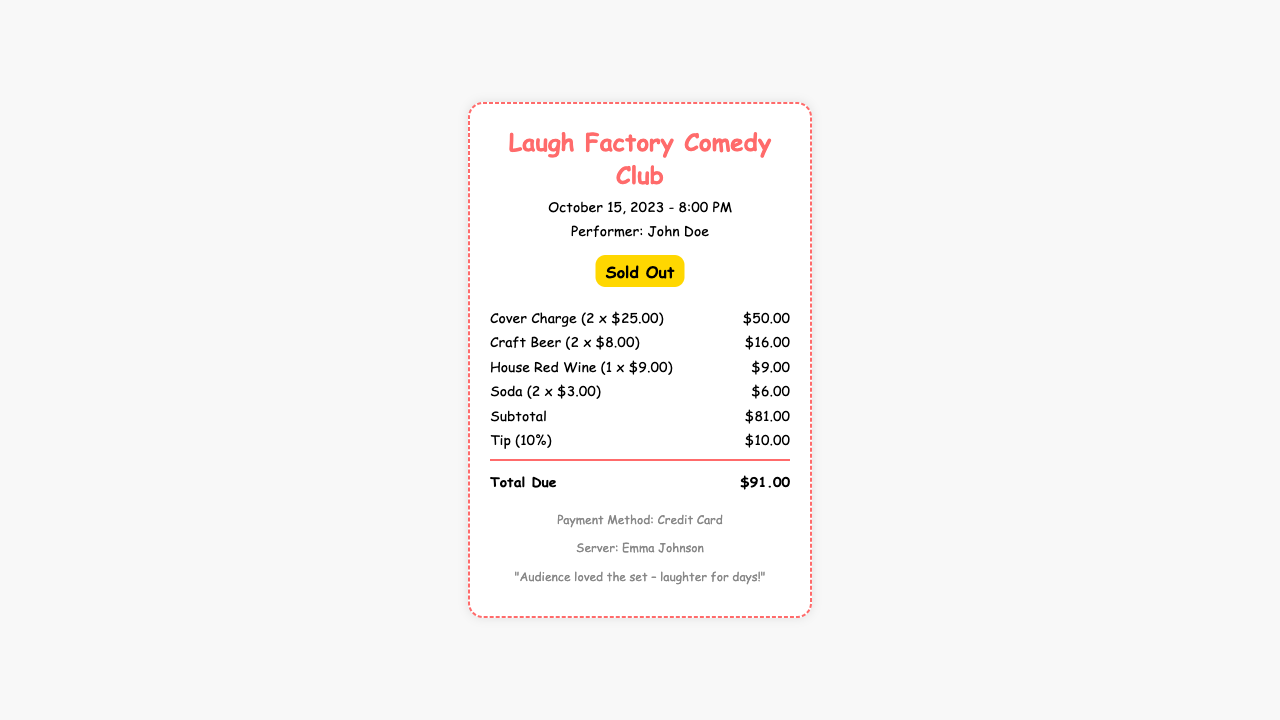What is the date of the show? The date of the show is clearly mentioned in the header of the receipt.
Answer: October 15, 2023 What is the cover charge for one person? The receipt lists the cover charge per person, which is calculated and displayed.
Answer: $25.00 How many drinks were ordered in total? The receipt itemizes the drinks ordered and sums them up in total quantities.
Answer: 5 Who was the performer? The receipt explicitly states the name of the performer at the show.
Answer: John Doe What was the total amount of tips received? The tip amount is specified in the receipt, which is based on the subtotal.
Answer: $10.00 What was the payment method used? The payment method is mentioned in the footer of the receipt.
Answer: Credit Card How much was spent on craft beer? The cost of craft beer is listed with the quantity and unit price.
Answer: $16.00 What does the status indicate about ticket availability? The receipt has a specific label indicating the availability of tickets at the show.
Answer: Sold Out What type of wine was ordered? The receipt lists the specific type of wine ordered with its price.
Answer: House Red Wine 